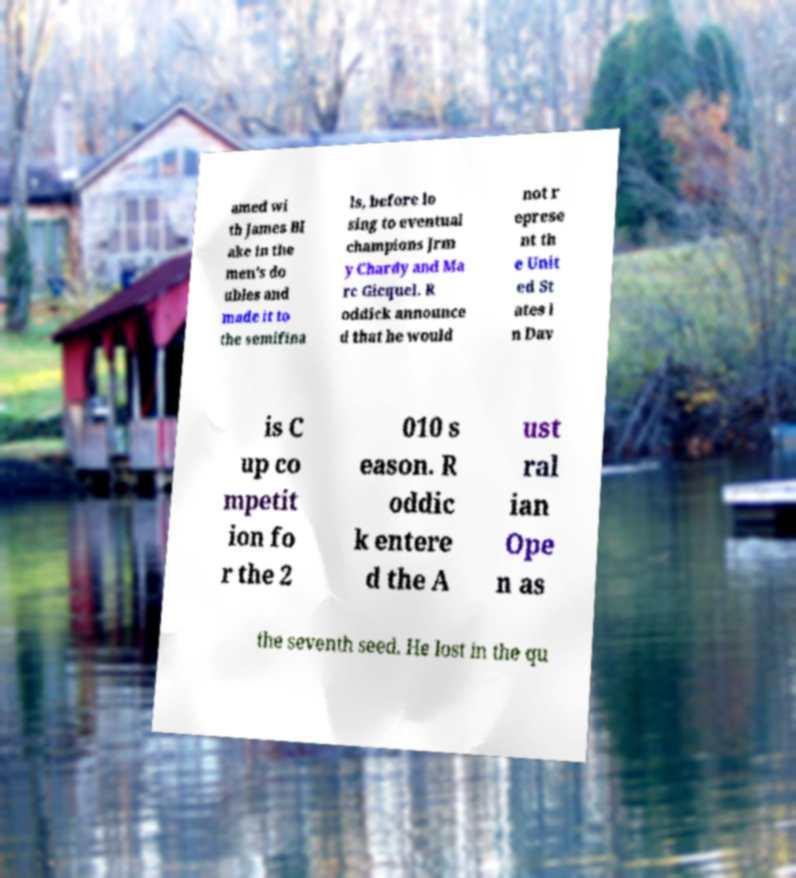Could you assist in decoding the text presented in this image and type it out clearly? amed wi th James Bl ake in the men's do ubles and made it to the semifina ls, before lo sing to eventual champions Jrm y Chardy and Ma rc Gicquel. R oddick announce d that he would not r eprese nt th e Unit ed St ates i n Dav is C up co mpetit ion fo r the 2 010 s eason. R oddic k entere d the A ust ral ian Ope n as the seventh seed. He lost in the qu 